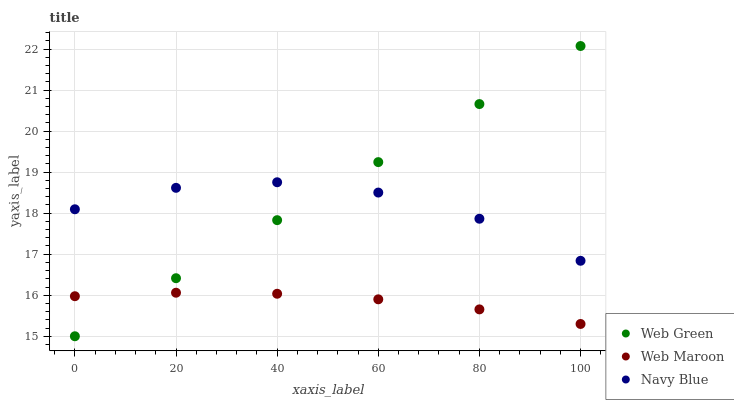Does Web Maroon have the minimum area under the curve?
Answer yes or no. Yes. Does Web Green have the maximum area under the curve?
Answer yes or no. Yes. Does Web Green have the minimum area under the curve?
Answer yes or no. No. Does Web Maroon have the maximum area under the curve?
Answer yes or no. No. Is Web Green the smoothest?
Answer yes or no. Yes. Is Navy Blue the roughest?
Answer yes or no. Yes. Is Web Maroon the smoothest?
Answer yes or no. No. Is Web Maroon the roughest?
Answer yes or no. No. Does Web Green have the lowest value?
Answer yes or no. Yes. Does Web Maroon have the lowest value?
Answer yes or no. No. Does Web Green have the highest value?
Answer yes or no. Yes. Does Web Maroon have the highest value?
Answer yes or no. No. Is Web Maroon less than Navy Blue?
Answer yes or no. Yes. Is Navy Blue greater than Web Maroon?
Answer yes or no. Yes. Does Web Green intersect Web Maroon?
Answer yes or no. Yes. Is Web Green less than Web Maroon?
Answer yes or no. No. Is Web Green greater than Web Maroon?
Answer yes or no. No. Does Web Maroon intersect Navy Blue?
Answer yes or no. No. 